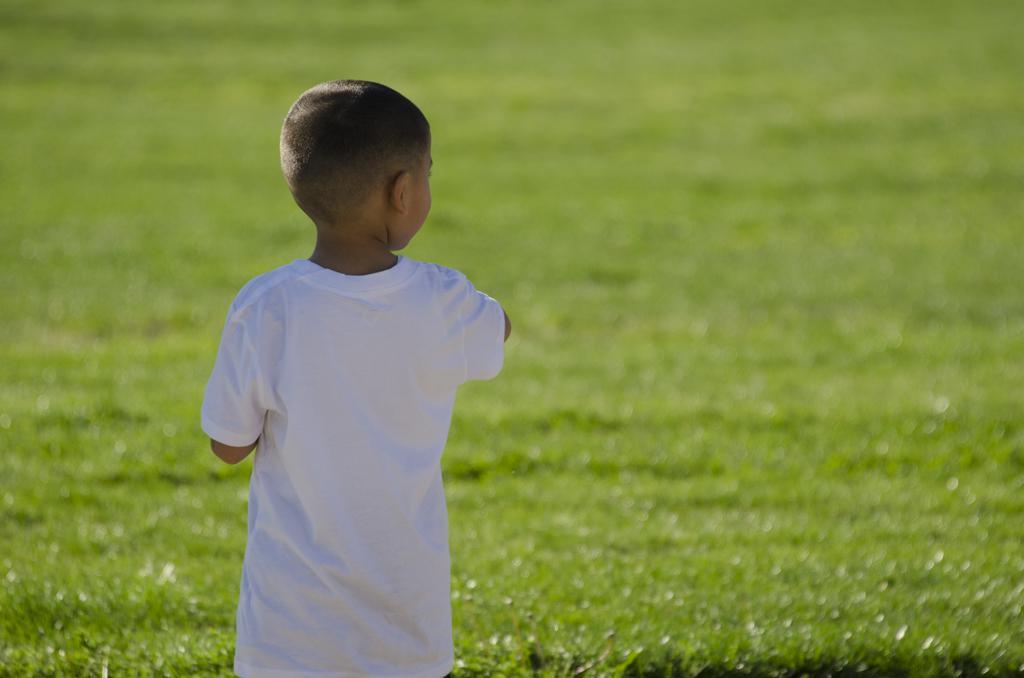Could you give a brief overview of what you see in this image? In this image we can see there is a boy standing on the surface of the grass. 